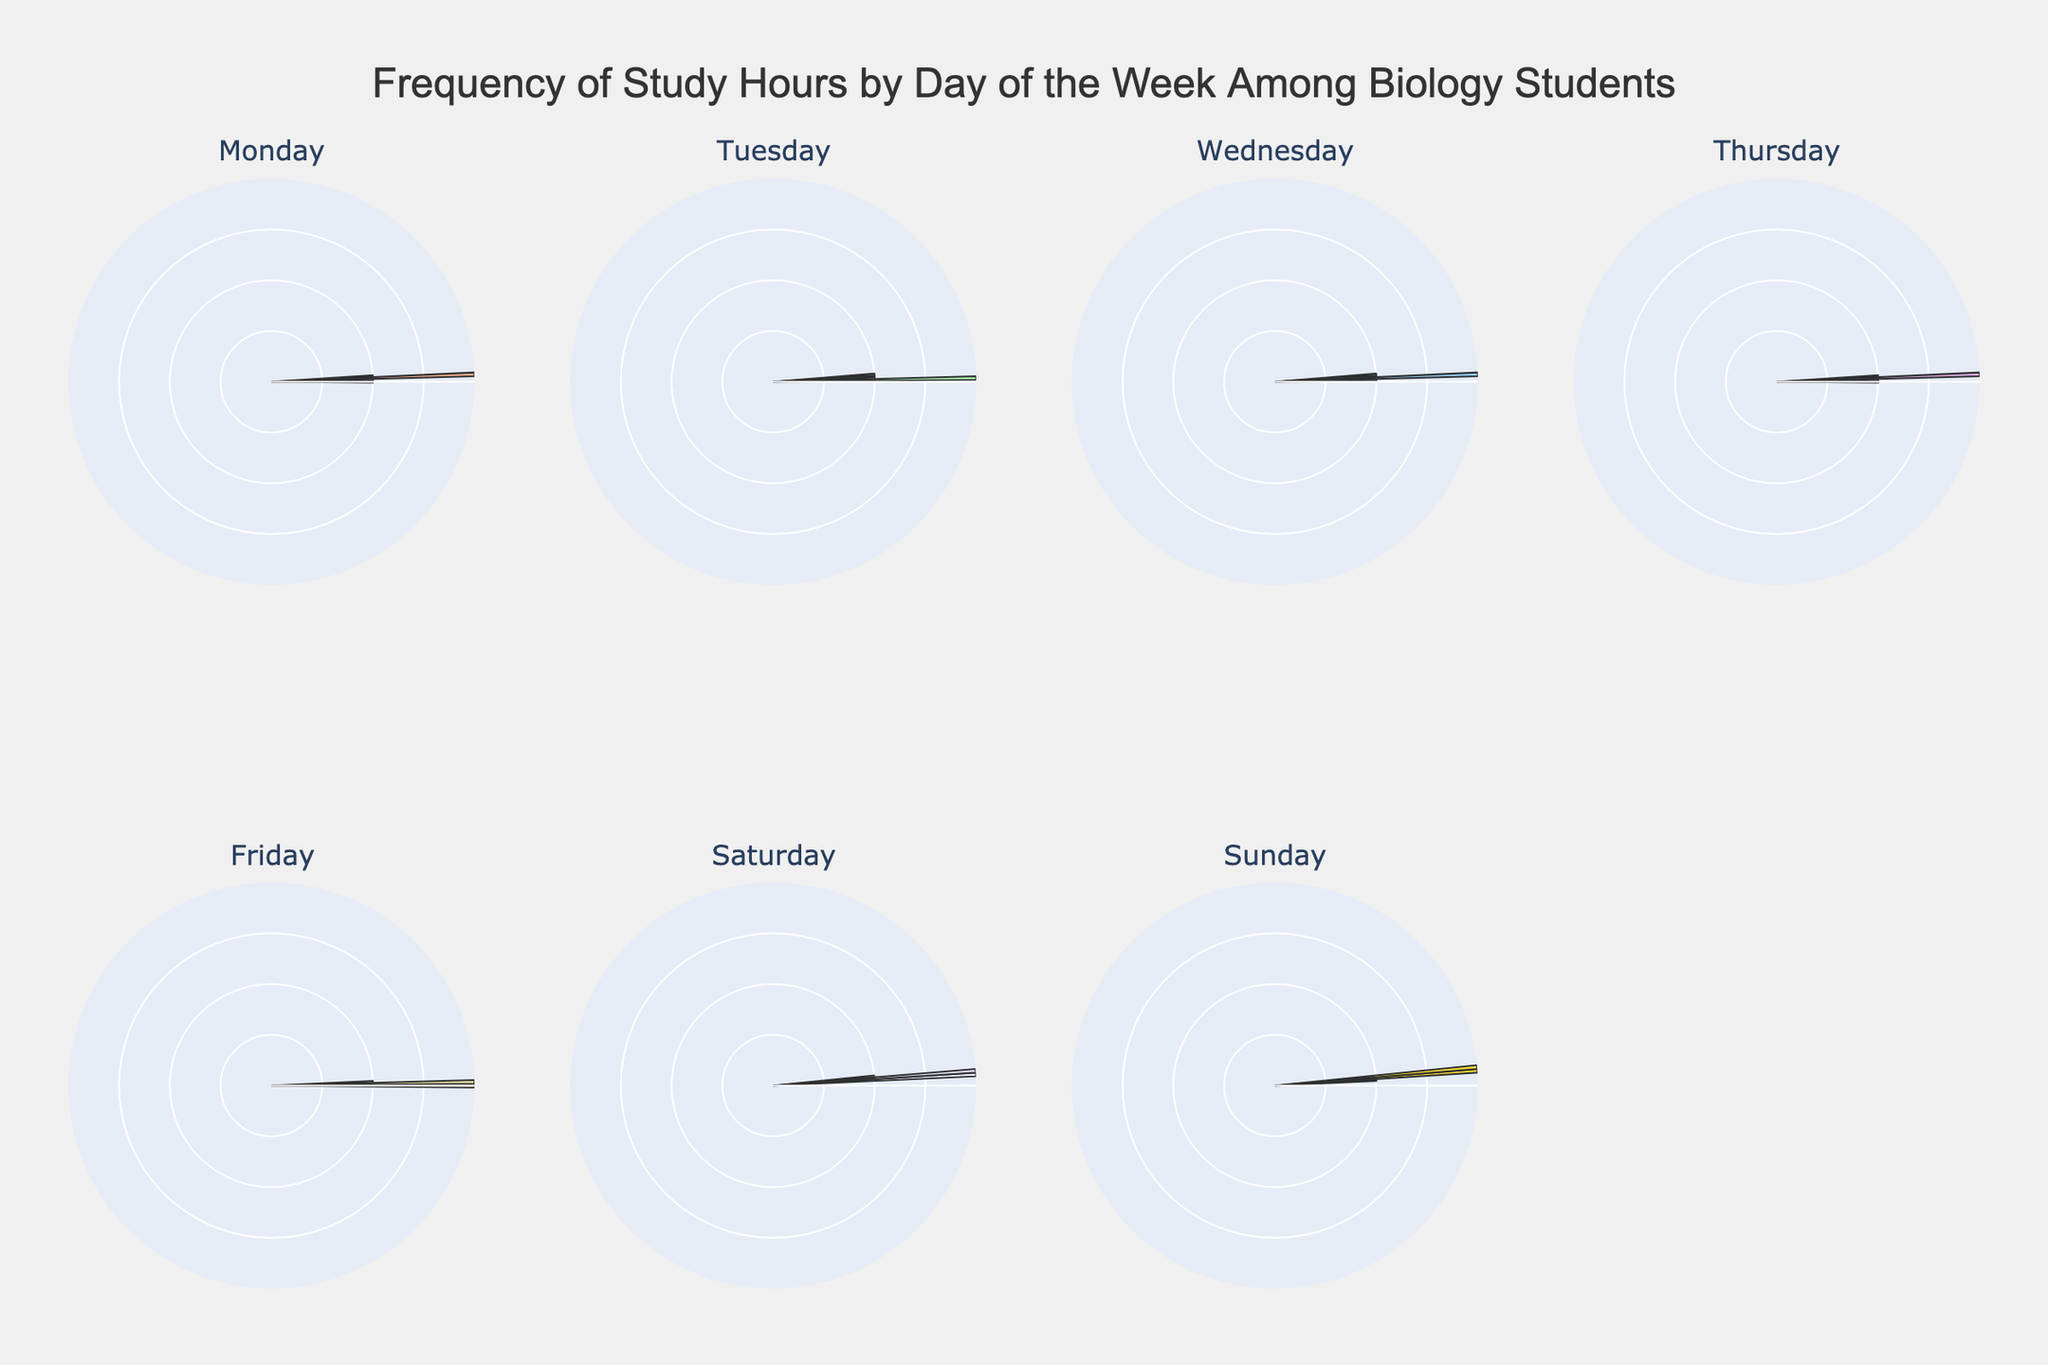what is the title of the figure? The title of the figure is on the top of the plot and reads "Frequency of Study Hours by Day of the Week Among Biology Students"
Answer: Frequency of Study Hours by Day of the Week Among Biology Students what are the names of the days displayed in the figure? The days of the week are shown as subplot titles in the figure. They are "Monday", "Tuesday", "Wednesday", "Thursday", "Friday", "Saturday", and "Sunday".
Answer: Monday, Tuesday, Wednesday, Thursday, Friday, Saturday, Sunday which day shows the highest frequency of 6-hour study sessions? By looking at each polar subplot's petals length, "Sunday" shows a frequency of 6-hour study sessions, as seen by the outermost petal.
Answer: Sunday what color is used to represent Thursday? The color used for Thursday is distinct for that subplot and appears as '#DDA0DD' (or a light purple).
Answer: light purple how does the frequency of 4-hour study sessions compare between Saturday and Sunday? By comparing the height of the petals marked for 4-hour study sessions between "Saturday" and "Sunday" subplots, "Sunday" has fewer petals than "Saturday", indicating lesser frequency.
Answer: Saturday is higher than Sunday what is the median study hour frequency on Wednesday? First, check the plot for the study frequency values for each hour on Wednesday (sorted order: 2, 3, 3, 4, 5), and find the median, which is the 3-hour session as it is the middle value.
Answer: 3-hour session what is the sum of the frequencies of study hours on Tuesday and Thursday? Total frequency for Tuesday (2, 2 + 4, 2, 5=6 + 4 ≈):2 + (5+4+2)=7 and total frequency for Thursday =3+4+4+3=14. Summing, we get 19.
Answer: 19 which day has the more consistent distribution of study hours across different hour durations? For more consistent distribution, each hour should appear frequently. "Thursday" shows more equal frequencies across hour categories compared to other days.
Answer: Thursday 